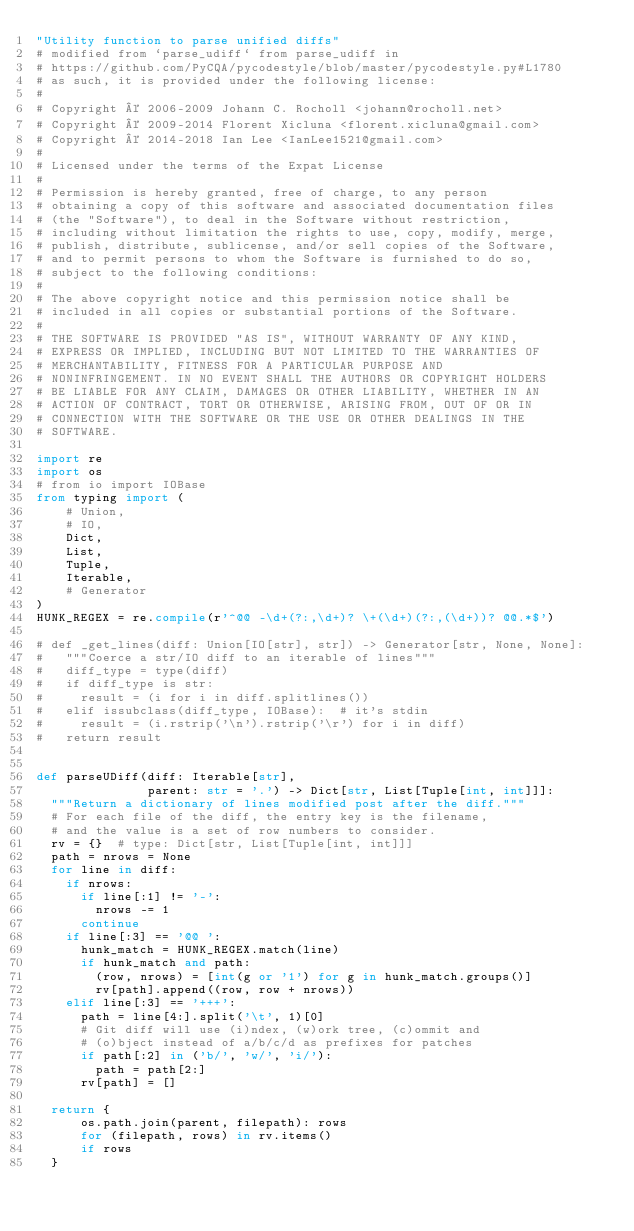<code> <loc_0><loc_0><loc_500><loc_500><_Python_>"Utility function to parse unified diffs"
# modified from `parse_udiff` from parse_udiff in
# https://github.com/PyCQA/pycodestyle/blob/master/pycodestyle.py#L1780
# as such, it is provided under the following license:
#
# Copyright © 2006-2009 Johann C. Rocholl <johann@rocholl.net>
# Copyright © 2009-2014 Florent Xicluna <florent.xicluna@gmail.com>
# Copyright © 2014-2018 Ian Lee <IanLee1521@gmail.com>
#
# Licensed under the terms of the Expat License
#
# Permission is hereby granted, free of charge, to any person
# obtaining a copy of this software and associated documentation files
# (the "Software"), to deal in the Software without restriction,
# including without limitation the rights to use, copy, modify, merge,
# publish, distribute, sublicense, and/or sell copies of the Software,
# and to permit persons to whom the Software is furnished to do so,
# subject to the following conditions:
#
# The above copyright notice and this permission notice shall be
# included in all copies or substantial portions of the Software.
#
# THE SOFTWARE IS PROVIDED "AS IS", WITHOUT WARRANTY OF ANY KIND,
# EXPRESS OR IMPLIED, INCLUDING BUT NOT LIMITED TO THE WARRANTIES OF
# MERCHANTABILITY, FITNESS FOR A PARTICULAR PURPOSE AND
# NONINFRINGEMENT. IN NO EVENT SHALL THE AUTHORS OR COPYRIGHT HOLDERS
# BE LIABLE FOR ANY CLAIM, DAMAGES OR OTHER LIABILITY, WHETHER IN AN
# ACTION OF CONTRACT, TORT OR OTHERWISE, ARISING FROM, OUT OF OR IN
# CONNECTION WITH THE SOFTWARE OR THE USE OR OTHER DEALINGS IN THE
# SOFTWARE.

import re
import os
# from io import IOBase
from typing import (
    # Union,
    # IO,
    Dict,
    List,
    Tuple,
    Iterable,
    # Generator
)
HUNK_REGEX = re.compile(r'^@@ -\d+(?:,\d+)? \+(\d+)(?:,(\d+))? @@.*$')

# def _get_lines(diff: Union[IO[str], str]) -> Generator[str, None, None]:
#   """Coerce a str/IO diff to an iterable of lines"""
#   diff_type = type(diff)
#   if diff_type is str:
#     result = (i for i in diff.splitlines())
#   elif issubclass(diff_type, IOBase):  # it's stdin
#     result = (i.rstrip('\n').rstrip('\r') for i in diff)
#   return result


def parseUDiff(diff: Iterable[str],
               parent: str = '.') -> Dict[str, List[Tuple[int, int]]]:
  """Return a dictionary of lines modified post after the diff."""
  # For each file of the diff, the entry key is the filename,
  # and the value is a set of row numbers to consider.
  rv = {}  # type: Dict[str, List[Tuple[int, int]]]
  path = nrows = None
  for line in diff:
    if nrows:
      if line[:1] != '-':
        nrows -= 1
      continue
    if line[:3] == '@@ ':
      hunk_match = HUNK_REGEX.match(line)
      if hunk_match and path:
        (row, nrows) = [int(g or '1') for g in hunk_match.groups()]
        rv[path].append((row, row + nrows))
    elif line[:3] == '+++':
      path = line[4:].split('\t', 1)[0]
      # Git diff will use (i)ndex, (w)ork tree, (c)ommit and
      # (o)bject instead of a/b/c/d as prefixes for patches
      if path[:2] in ('b/', 'w/', 'i/'):
        path = path[2:]
      rv[path] = []

  return {
      os.path.join(parent, filepath): rows
      for (filepath, rows) in rv.items()
      if rows
  }
</code> 